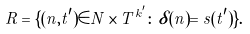<formula> <loc_0><loc_0><loc_500><loc_500>R = \{ ( n , t ^ { \prime } ) \in N \times T ^ { k ^ { \prime } } \colon \delta ( n ) = s ( t ^ { \prime } ) \} .</formula> 